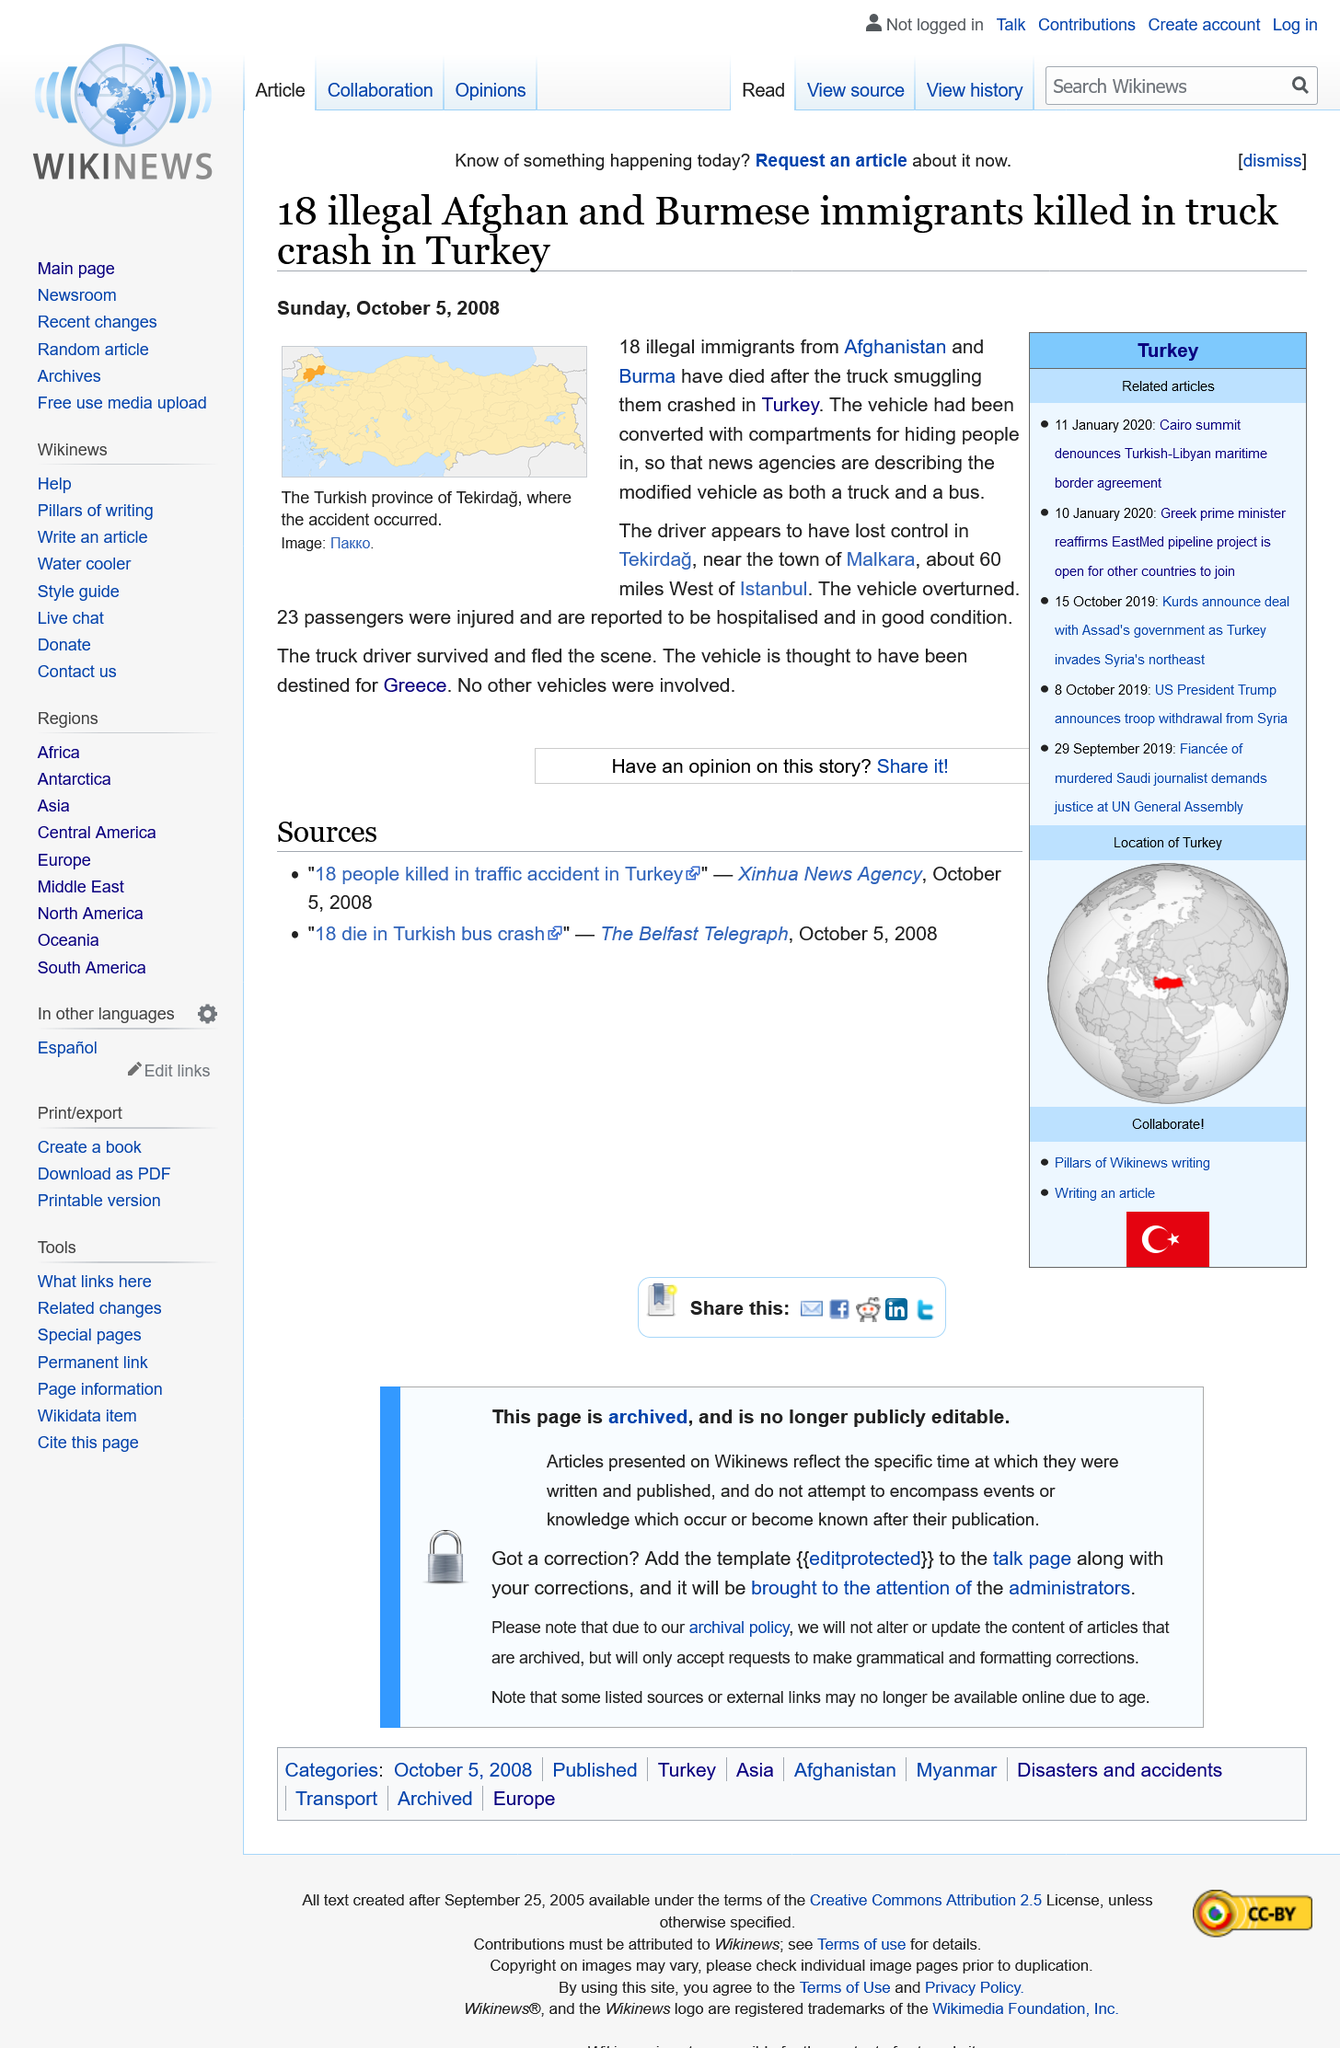Give some essential details in this illustration. The illegal immigrants were from Afghanistan and Burma, and they were illegally present in the United States. The vehicle overturned in Tekirdag and 23 passengers were injured as a result. The truck driver survived the incident. 